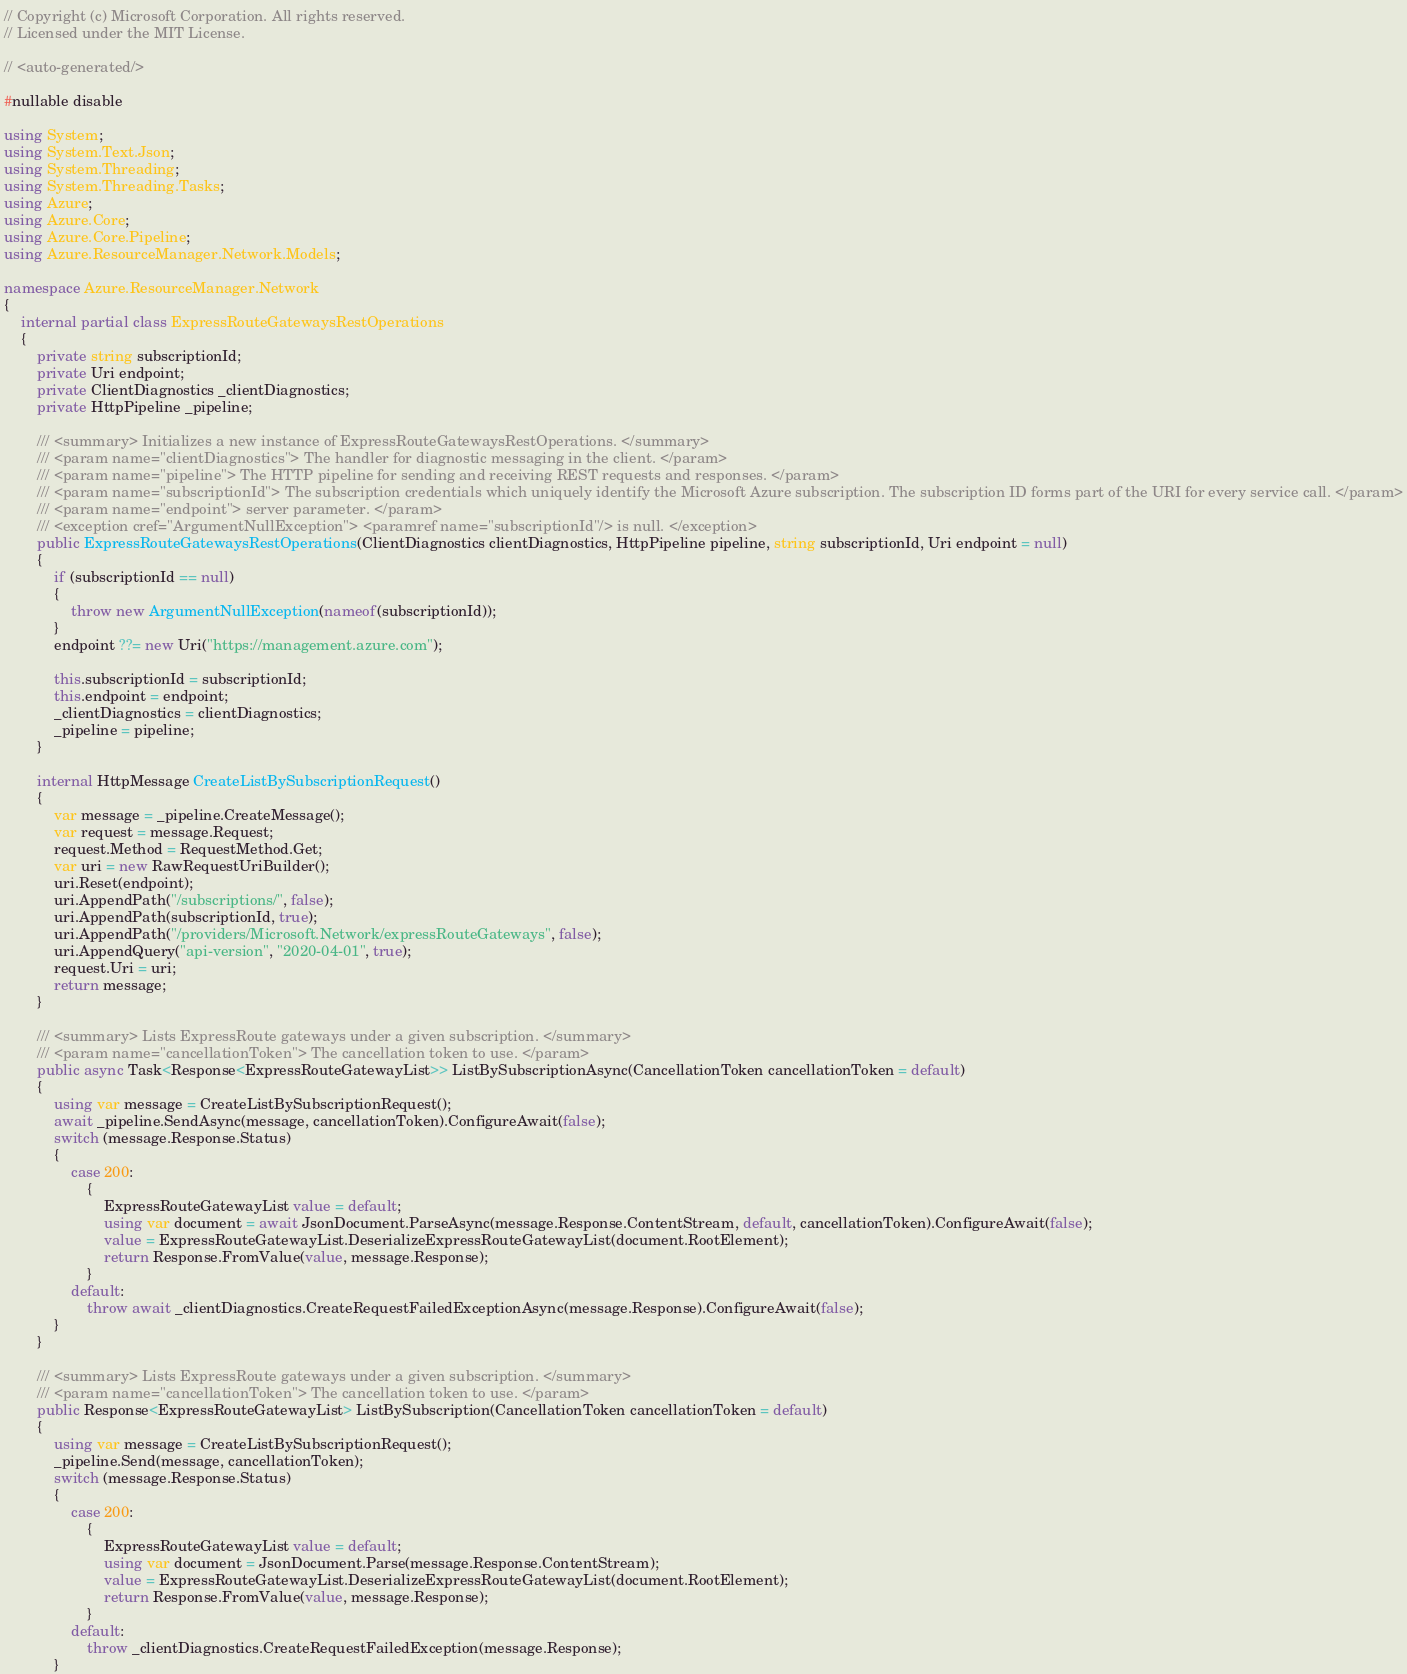Convert code to text. <code><loc_0><loc_0><loc_500><loc_500><_C#_>// Copyright (c) Microsoft Corporation. All rights reserved.
// Licensed under the MIT License.

// <auto-generated/>

#nullable disable

using System;
using System.Text.Json;
using System.Threading;
using System.Threading.Tasks;
using Azure;
using Azure.Core;
using Azure.Core.Pipeline;
using Azure.ResourceManager.Network.Models;

namespace Azure.ResourceManager.Network
{
    internal partial class ExpressRouteGatewaysRestOperations
    {
        private string subscriptionId;
        private Uri endpoint;
        private ClientDiagnostics _clientDiagnostics;
        private HttpPipeline _pipeline;

        /// <summary> Initializes a new instance of ExpressRouteGatewaysRestOperations. </summary>
        /// <param name="clientDiagnostics"> The handler for diagnostic messaging in the client. </param>
        /// <param name="pipeline"> The HTTP pipeline for sending and receiving REST requests and responses. </param>
        /// <param name="subscriptionId"> The subscription credentials which uniquely identify the Microsoft Azure subscription. The subscription ID forms part of the URI for every service call. </param>
        /// <param name="endpoint"> server parameter. </param>
        /// <exception cref="ArgumentNullException"> <paramref name="subscriptionId"/> is null. </exception>
        public ExpressRouteGatewaysRestOperations(ClientDiagnostics clientDiagnostics, HttpPipeline pipeline, string subscriptionId, Uri endpoint = null)
        {
            if (subscriptionId == null)
            {
                throw new ArgumentNullException(nameof(subscriptionId));
            }
            endpoint ??= new Uri("https://management.azure.com");

            this.subscriptionId = subscriptionId;
            this.endpoint = endpoint;
            _clientDiagnostics = clientDiagnostics;
            _pipeline = pipeline;
        }

        internal HttpMessage CreateListBySubscriptionRequest()
        {
            var message = _pipeline.CreateMessage();
            var request = message.Request;
            request.Method = RequestMethod.Get;
            var uri = new RawRequestUriBuilder();
            uri.Reset(endpoint);
            uri.AppendPath("/subscriptions/", false);
            uri.AppendPath(subscriptionId, true);
            uri.AppendPath("/providers/Microsoft.Network/expressRouteGateways", false);
            uri.AppendQuery("api-version", "2020-04-01", true);
            request.Uri = uri;
            return message;
        }

        /// <summary> Lists ExpressRoute gateways under a given subscription. </summary>
        /// <param name="cancellationToken"> The cancellation token to use. </param>
        public async Task<Response<ExpressRouteGatewayList>> ListBySubscriptionAsync(CancellationToken cancellationToken = default)
        {
            using var message = CreateListBySubscriptionRequest();
            await _pipeline.SendAsync(message, cancellationToken).ConfigureAwait(false);
            switch (message.Response.Status)
            {
                case 200:
                    {
                        ExpressRouteGatewayList value = default;
                        using var document = await JsonDocument.ParseAsync(message.Response.ContentStream, default, cancellationToken).ConfigureAwait(false);
                        value = ExpressRouteGatewayList.DeserializeExpressRouteGatewayList(document.RootElement);
                        return Response.FromValue(value, message.Response);
                    }
                default:
                    throw await _clientDiagnostics.CreateRequestFailedExceptionAsync(message.Response).ConfigureAwait(false);
            }
        }

        /// <summary> Lists ExpressRoute gateways under a given subscription. </summary>
        /// <param name="cancellationToken"> The cancellation token to use. </param>
        public Response<ExpressRouteGatewayList> ListBySubscription(CancellationToken cancellationToken = default)
        {
            using var message = CreateListBySubscriptionRequest();
            _pipeline.Send(message, cancellationToken);
            switch (message.Response.Status)
            {
                case 200:
                    {
                        ExpressRouteGatewayList value = default;
                        using var document = JsonDocument.Parse(message.Response.ContentStream);
                        value = ExpressRouteGatewayList.DeserializeExpressRouteGatewayList(document.RootElement);
                        return Response.FromValue(value, message.Response);
                    }
                default:
                    throw _clientDiagnostics.CreateRequestFailedException(message.Response);
            }</code> 